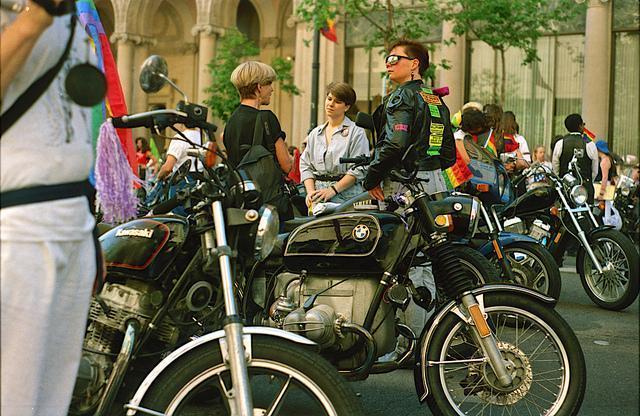How many people are visible?
Give a very brief answer. 4. How many motorcycles are there?
Give a very brief answer. 4. How many backpacks are there?
Give a very brief answer. 2. 